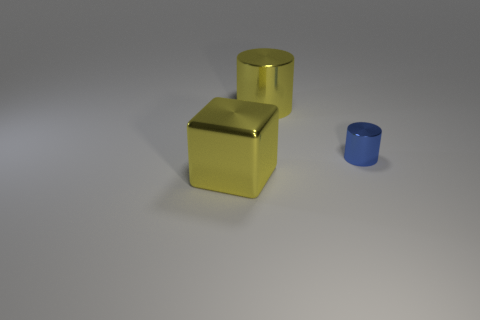The thing that is the same color as the big metal cube is what shape?
Offer a terse response. Cylinder. Are there an equal number of large metal cubes that are behind the large yellow metal cylinder and tiny shiny balls?
Ensure brevity in your answer.  Yes. There is a yellow block; does it have the same size as the cylinder left of the blue metal object?
Keep it short and to the point. Yes. What number of large yellow cylinders have the same material as the blue cylinder?
Keep it short and to the point. 1. Do the yellow cylinder and the cube have the same size?
Provide a succinct answer. Yes. Is there anything else of the same color as the large cube?
Offer a terse response. Yes. There is a shiny thing that is both on the left side of the blue metal thing and in front of the big yellow metallic cylinder; what shape is it?
Make the answer very short. Cube. How big is the object behind the tiny cylinder?
Offer a terse response. Large. How many yellow things are behind the shiny object left of the cylinder behind the tiny thing?
Ensure brevity in your answer.  1. Are there any tiny cylinders left of the blue metal object?
Offer a very short reply. No. 